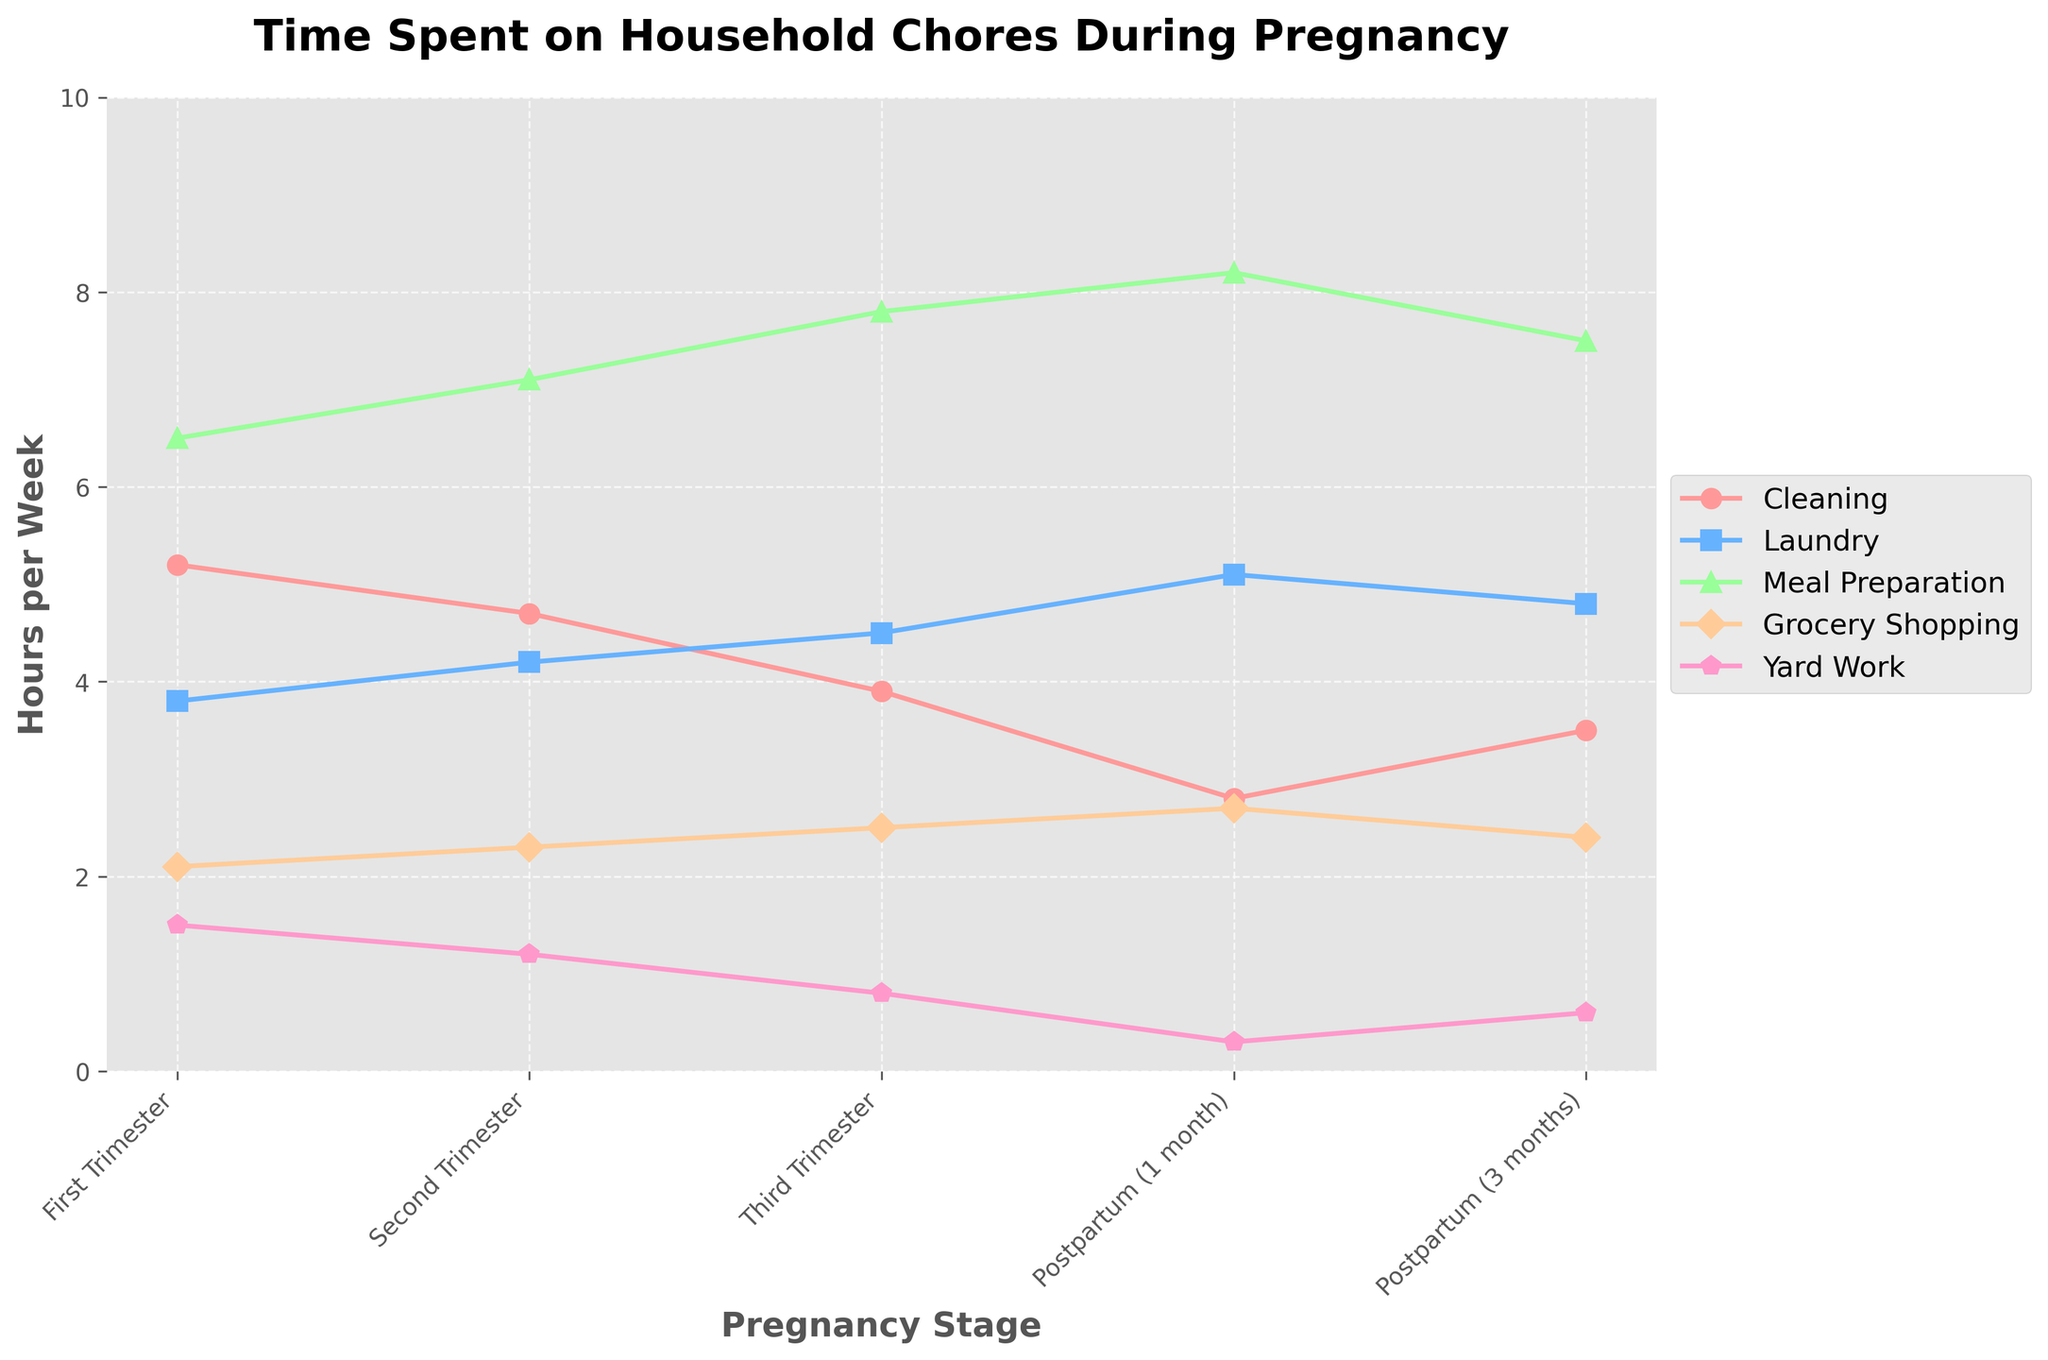Which household chore shows the most significant decrease in time spent from the First Trimester to Postpartum (1 month)? To find this, subtract the time spent on each chore in Postpartum (1 month) from that in the First Trimester. Compare these values to determine the largest decrease. Cleaning decreases by 2.4 hours (5.2 - 2.8), Laundry by 1.3 hours (4.5 - 3.8), Meal Preparation by 1.7 hours (8.2 - 6.5), Grocery Shopping by 0.6 hours (2.7 - 2.1), and Yard Work by 1.2 hours (1.5 - 0.3). Cleaning has the largest decrease.
Answer: Cleaning Which trimester involves the most time spent on meal preparation? Compare the values for Meal Preparation across all trimesters. The First Trimester is 6.5 hours a week, the Second Trimester is 7.1 hours a week, Third Trimester is 7.8 hours a week, and Postpartum (1 month) is 8.2 hours a week. Postpartum (1 month) is not a trimester, so the Third Trimester has the most time spent on meal preparation.
Answer: Third Trimester What is the overall trend in the time spent on yard work from First Trimester to Postpartum (3 months)? Observe and compare the values for Yard Work across all pregnancy stages. The values decrease as follows: 1.5 hours in the First Trimester, 1.2 hours in the Second Trimester, 0.8 hours in the Third Trimester, 0.3 hours in Postpartum (1 month), and 0.6 hours in Postpartum (3 months). The overall trend is a decrease in time spent on yard work.
Answer: Decreasing Compare the time spent on laundry and grocery shopping during the Second Trimester. Which one is higher and by how much? Compare the values for Laundry (4.2 hours/week) and Grocery Shopping (2.3 hours/week). Subtract the smaller value from the larger one to find the difference: 4.2 - 2.3 = 1.9. Laundry is higher by 1.9 hours.
Answer: Laundry by 1.9 hours During which stage is the time spent on cleaning the least? Examine the values for Cleaning across all stages: First Trimester (5.2 hours), Second Trimester (4.7 hours), Third Trimester (3.9 hours), Postpartum (1 month) (2.8 hours), Postpartum (3 months) (3.5 hours). The lowest value is 2.8 hours in Postpartum (1 month).
Answer: Postpartum (1 month) How does the time spent on grocery shopping change from the Third Trimester to Postpartum (3 months)? Compare the values for Grocery Shopping in the Third Trimester (2.5 hours/week) and Postpartum (3 months) (2.4 hours/week). The time decreases slightly by 0.1 hour (2.5 - 2.4).
Answer: Decreases by 0.1 hour If you sum up the time spent on all chores during the Second Trimester, what is the total? Add the time spent on all chores in the Second Trimester: Cleaning (4.7), Laundry (4.2), Meal Preparation (7.1), Grocery Shopping (2.3), and Yard Work (1.2). The total is 4.7 + 4.2 + 7.1 + 2.3 + 1.2 = 19.5 hours.
Answer: 19.5 hours Which household chore remains nearly consistent across all pregnancy stages? Look for a chore that shows minimal change across all stages. Meal Preparation seems most consistent: 6.5 (First Trimester), 7.1 (Second Trimester), 7.8 (Third Trimester), 8.2 (Postpartum 1 month), 7.5 (Postpartum 3 months). The values do not vary widely.
Answer: Meal Preparation 